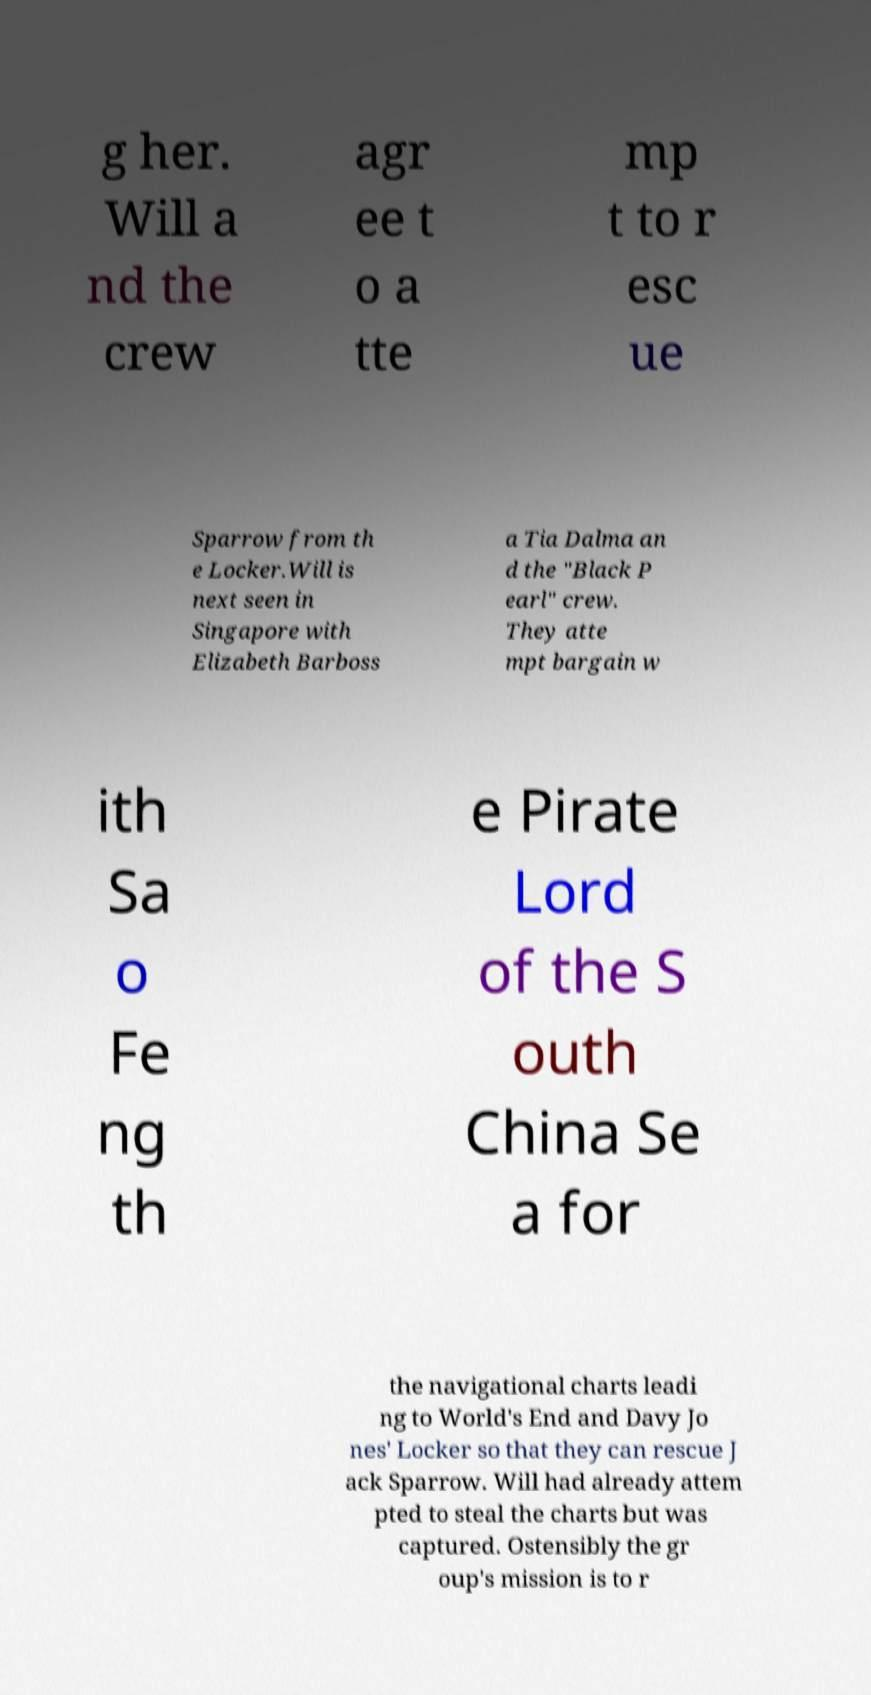I need the written content from this picture converted into text. Can you do that? g her. Will a nd the crew agr ee t o a tte mp t to r esc ue Sparrow from th e Locker.Will is next seen in Singapore with Elizabeth Barboss a Tia Dalma an d the "Black P earl" crew. They atte mpt bargain w ith Sa o Fe ng th e Pirate Lord of the S outh China Se a for the navigational charts leadi ng to World's End and Davy Jo nes' Locker so that they can rescue J ack Sparrow. Will had already attem pted to steal the charts but was captured. Ostensibly the gr oup's mission is to r 